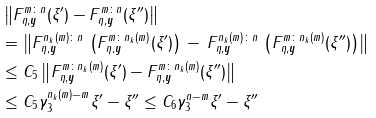<formula> <loc_0><loc_0><loc_500><loc_500>& \left \| F _ { \eta , \boldsymbol y } ^ { m \colon n } ( \xi ^ { \prime } ) - F _ { \eta , \boldsymbol y } ^ { m \colon n } ( \xi ^ { \prime \prime } ) \right \| \\ & = \left \| F _ { \eta , \boldsymbol y } ^ { n _ { k } ( m ) \colon n } \, \left ( F _ { \eta , \boldsymbol y } ^ { m \colon n _ { k } ( m ) } ( \xi ^ { \prime } ) \right ) \, - \, F _ { \eta , \boldsymbol y } ^ { n _ { k } ( m ) \colon n } \, \left ( F _ { \eta , \boldsymbol y } ^ { m \colon n _ { k } ( m ) } ( \xi ^ { \prime \prime } ) \right ) \right \| \\ & \leq C _ { 5 } \left \| F _ { \eta , \boldsymbol y } ^ { m \colon n _ { k } ( m ) } ( \xi ^ { \prime } ) - F _ { \eta , \boldsymbol y } ^ { m \colon n _ { k } ( m ) } ( \xi ^ { \prime \prime } ) \right \| \\ & \leq C _ { 5 } \gamma _ { 3 } ^ { n _ { k } ( m ) - m } \| \xi ^ { \prime } - \xi ^ { \prime \prime } \| \leq C _ { 6 } \gamma _ { 3 } ^ { n - m } \| \xi ^ { \prime } - \xi ^ { \prime \prime } \|</formula> 